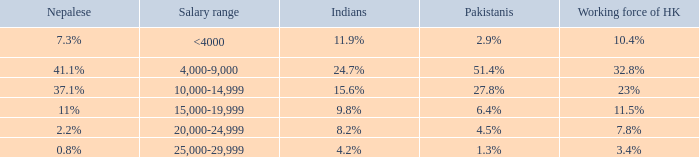If the Indians are 8.2%, what is the salary range? 20,000-24,999. 